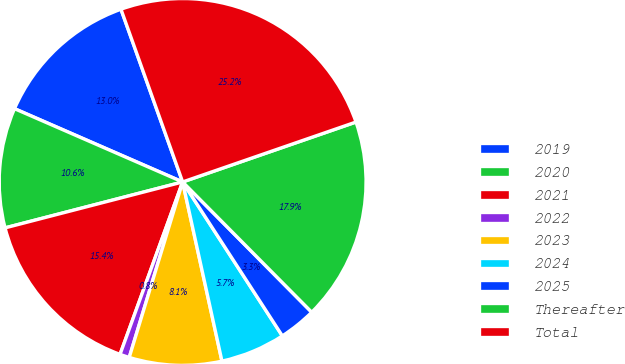Convert chart. <chart><loc_0><loc_0><loc_500><loc_500><pie_chart><fcel>2019<fcel>2020<fcel>2021<fcel>2022<fcel>2023<fcel>2024<fcel>2025<fcel>Thereafter<fcel>Total<nl><fcel>13.0%<fcel>10.57%<fcel>15.43%<fcel>0.84%<fcel>8.14%<fcel>5.71%<fcel>3.28%<fcel>17.87%<fcel>25.16%<nl></chart> 